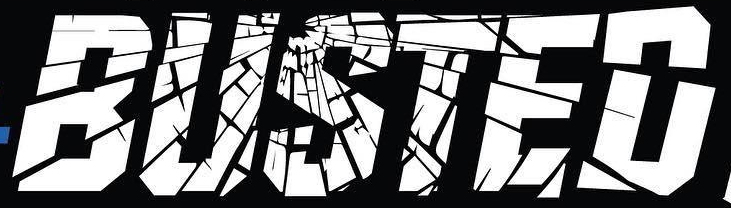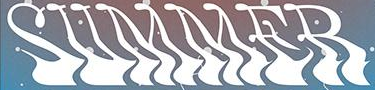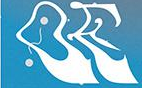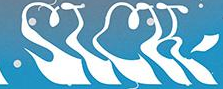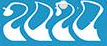What words are shown in these images in order, separated by a semicolon? BUSTED; SUMMER; OE; SICK; 2020 